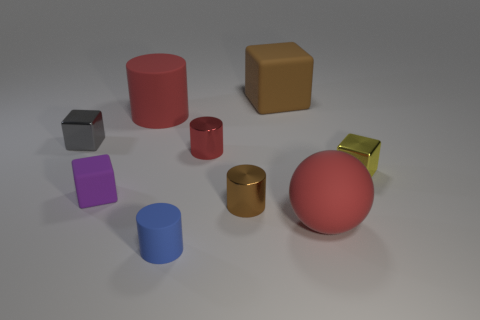Subtract all gray blocks. How many blocks are left? 3 Subtract all blue cylinders. How many cylinders are left? 3 Subtract all cylinders. How many objects are left? 5 Subtract 1 cylinders. How many cylinders are left? 3 Subtract all green cylinders. How many gray blocks are left? 1 Add 4 large red matte things. How many large red matte things are left? 6 Add 8 large rubber blocks. How many large rubber blocks exist? 9 Subtract 0 cyan cylinders. How many objects are left? 9 Subtract all brown blocks. Subtract all yellow cylinders. How many blocks are left? 3 Subtract all tiny blue metal cylinders. Subtract all tiny matte cylinders. How many objects are left? 8 